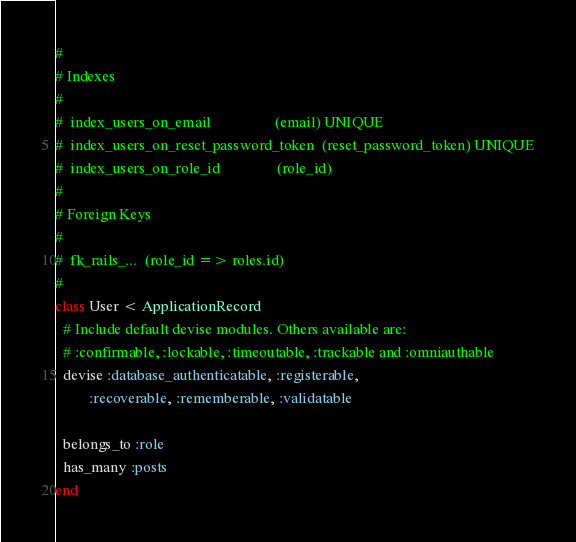Convert code to text. <code><loc_0><loc_0><loc_500><loc_500><_Ruby_>#
# Indexes
#
#  index_users_on_email                 (email) UNIQUE
#  index_users_on_reset_password_token  (reset_password_token) UNIQUE
#  index_users_on_role_id               (role_id)
#
# Foreign Keys
#
#  fk_rails_...  (role_id => roles.id)
#
class User < ApplicationRecord
  # Include default devise modules. Others available are:
  # :confirmable, :lockable, :timeoutable, :trackable and :omniauthable
  devise :database_authenticatable, :registerable,
         :recoverable, :rememberable, :validatable

  belongs_to :role
  has_many :posts
end
</code> 